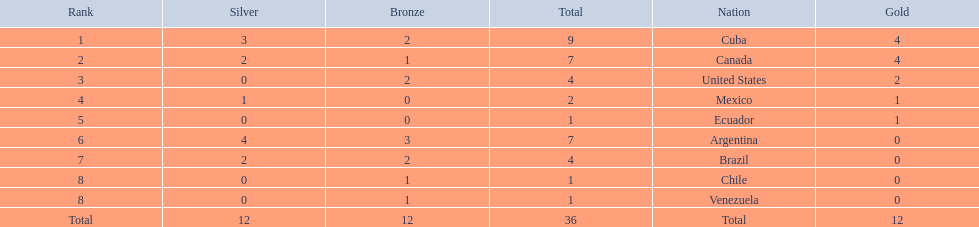Which nations won gold medals? Cuba, Canada, United States, Mexico, Ecuador. How many medals did each nation win? Cuba, 9, Canada, 7, United States, 4, Mexico, 2, Ecuador, 1. Which nation only won a gold medal? Ecuador. 